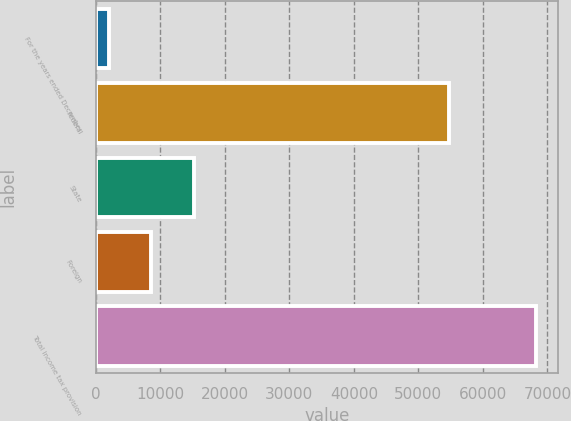<chart> <loc_0><loc_0><loc_500><loc_500><bar_chart><fcel>For the years ended December<fcel>Federal<fcel>State<fcel>Foreign<fcel>Total income tax provision<nl><fcel>2013<fcel>54778<fcel>15265.6<fcel>8639.3<fcel>68276<nl></chart> 